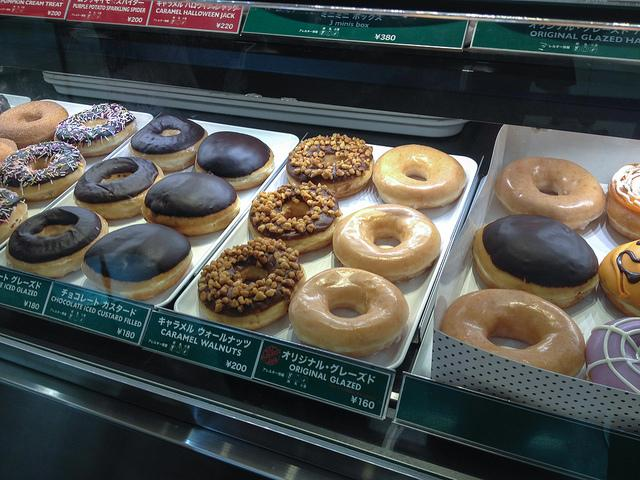Where can you buy these donuts? bakery 